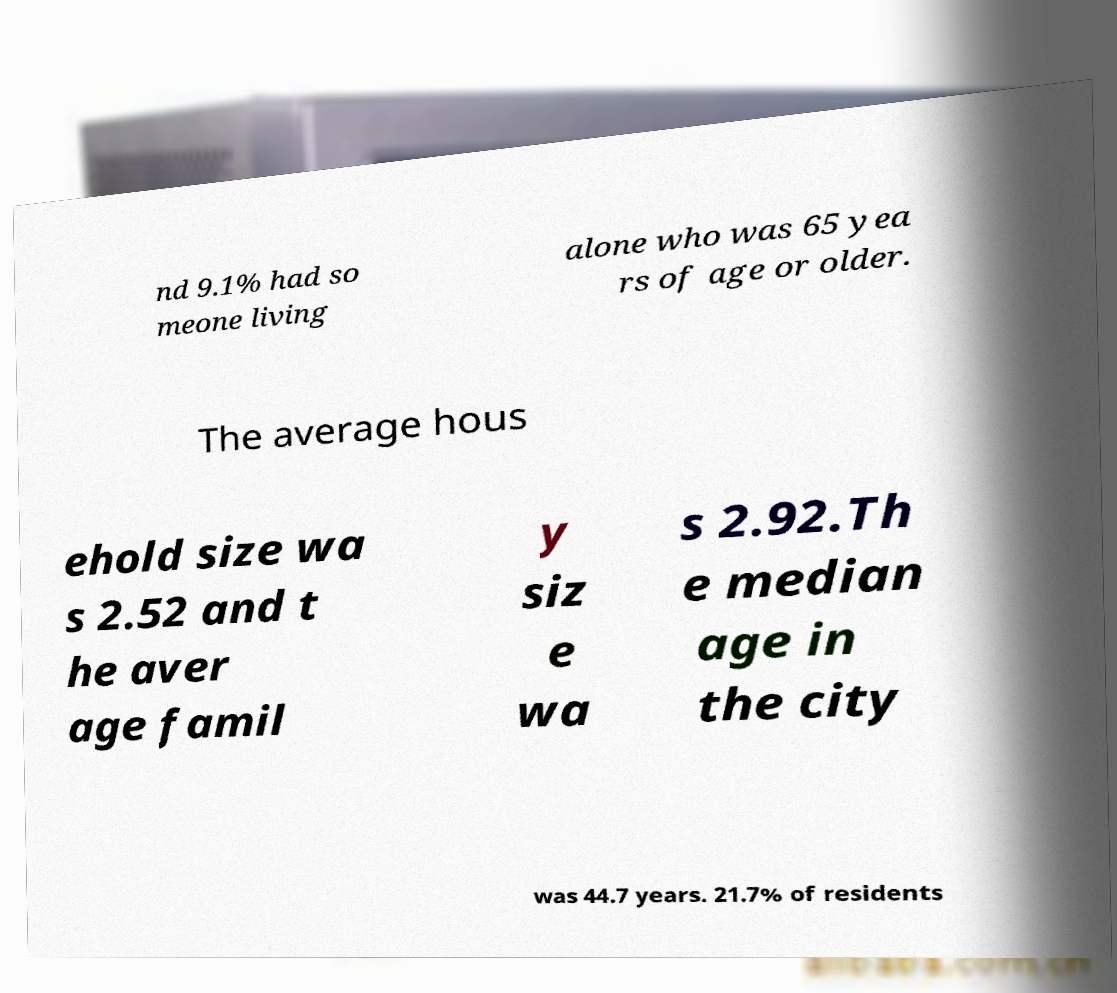Could you assist in decoding the text presented in this image and type it out clearly? nd 9.1% had so meone living alone who was 65 yea rs of age or older. The average hous ehold size wa s 2.52 and t he aver age famil y siz e wa s 2.92.Th e median age in the city was 44.7 years. 21.7% of residents 